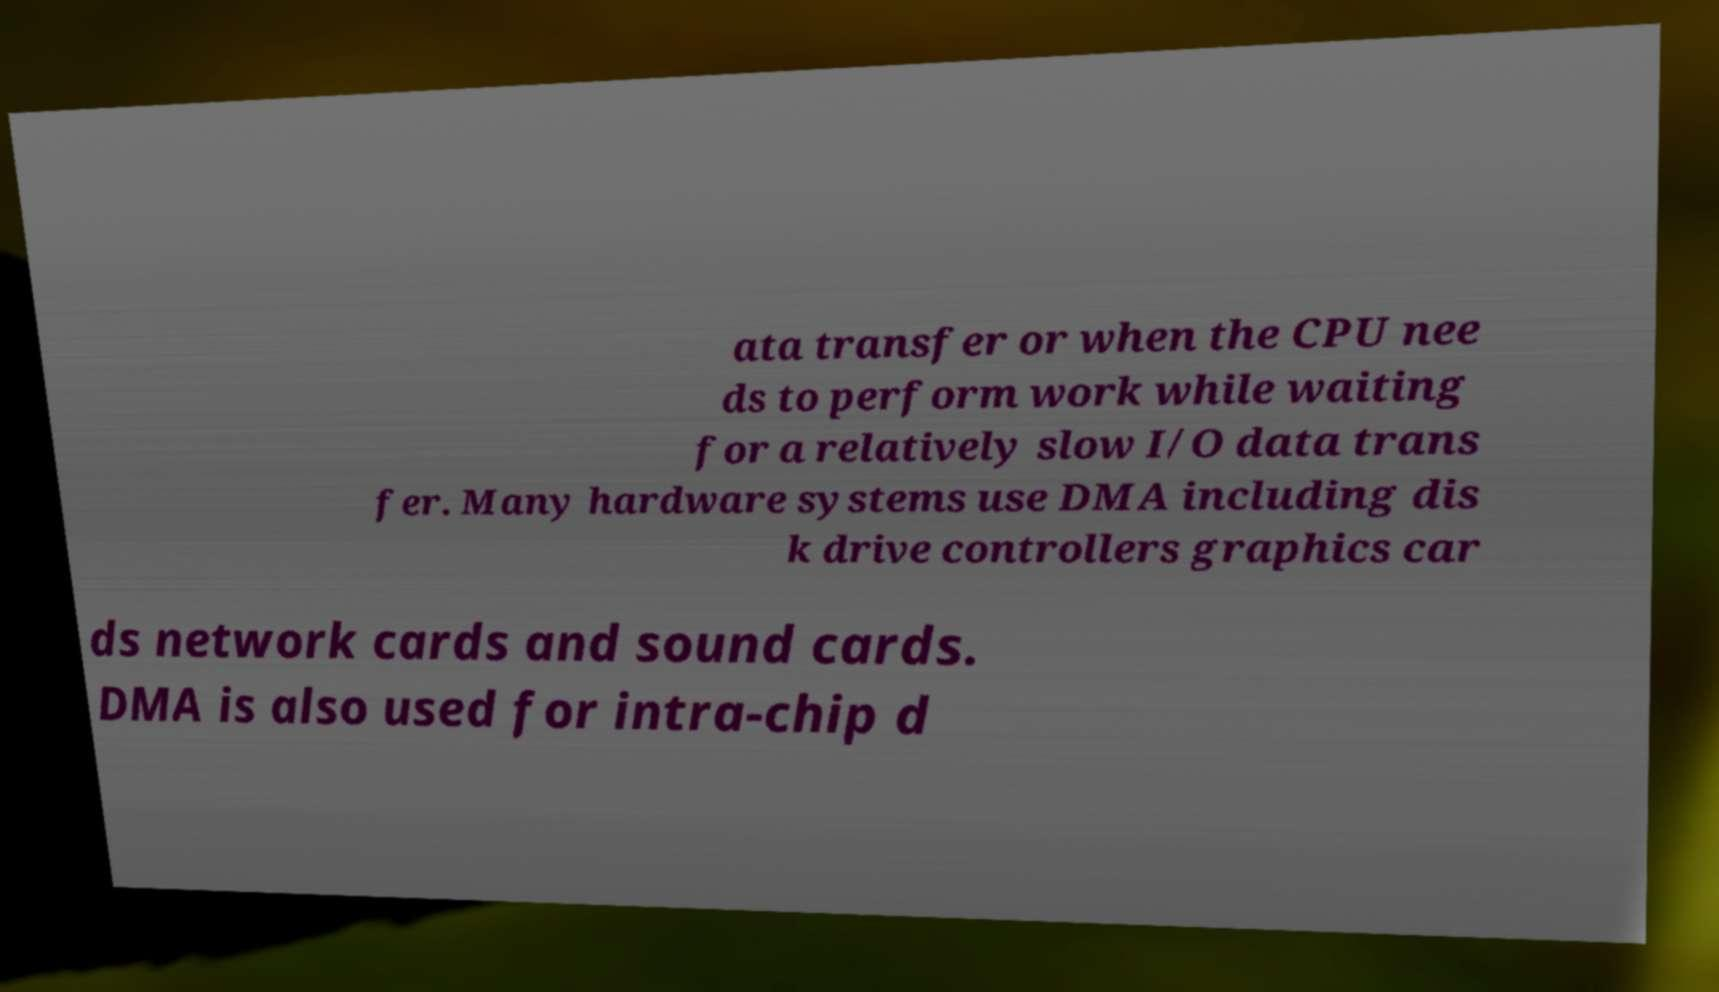Can you accurately transcribe the text from the provided image for me? ata transfer or when the CPU nee ds to perform work while waiting for a relatively slow I/O data trans fer. Many hardware systems use DMA including dis k drive controllers graphics car ds network cards and sound cards. DMA is also used for intra-chip d 